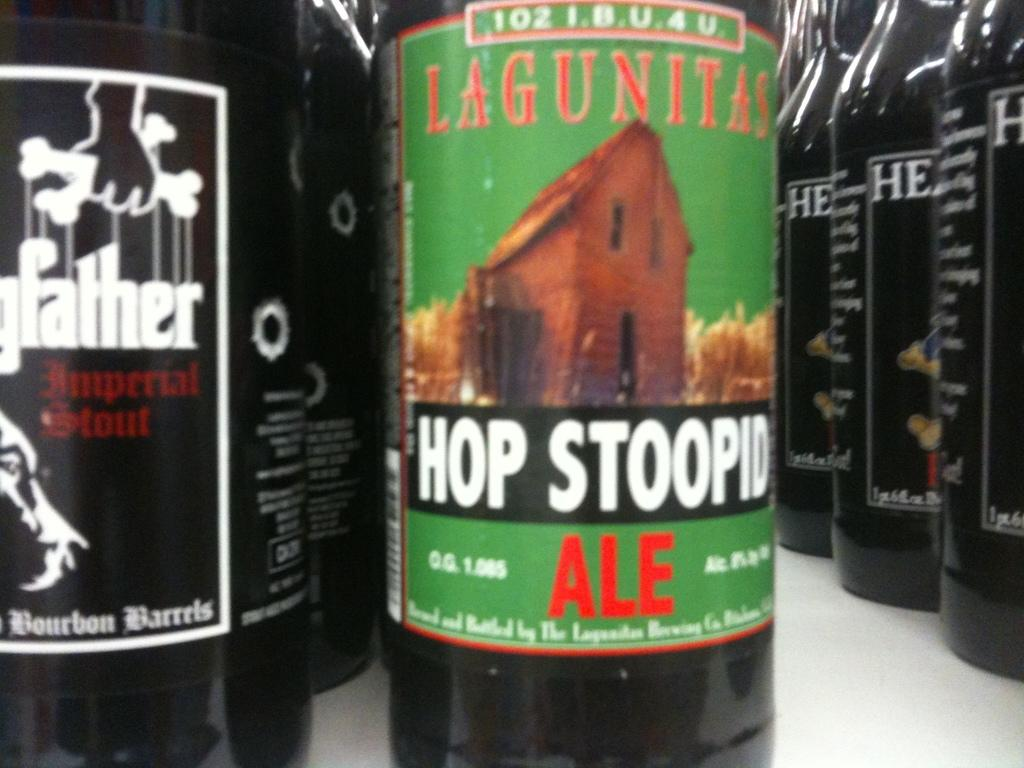<image>
Offer a succinct explanation of the picture presented. A glass bottle of Hop Stoopid Ale on top of a counter. 